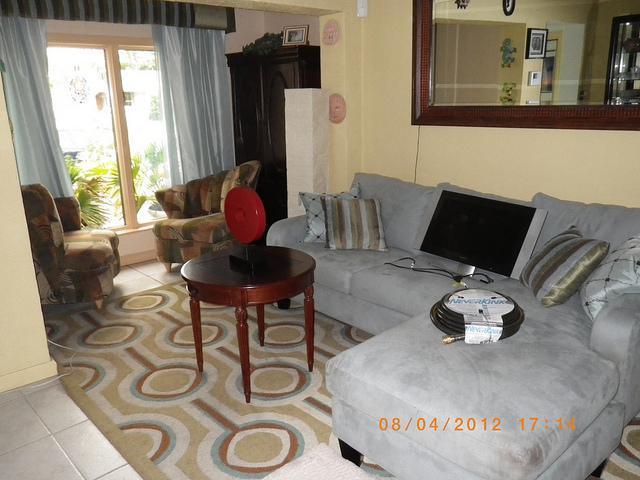How many pillows on the couch?
Give a very brief answer. 4. How many chairs are there?
Give a very brief answer. 2. How many giraffes are there?
Give a very brief answer. 0. 